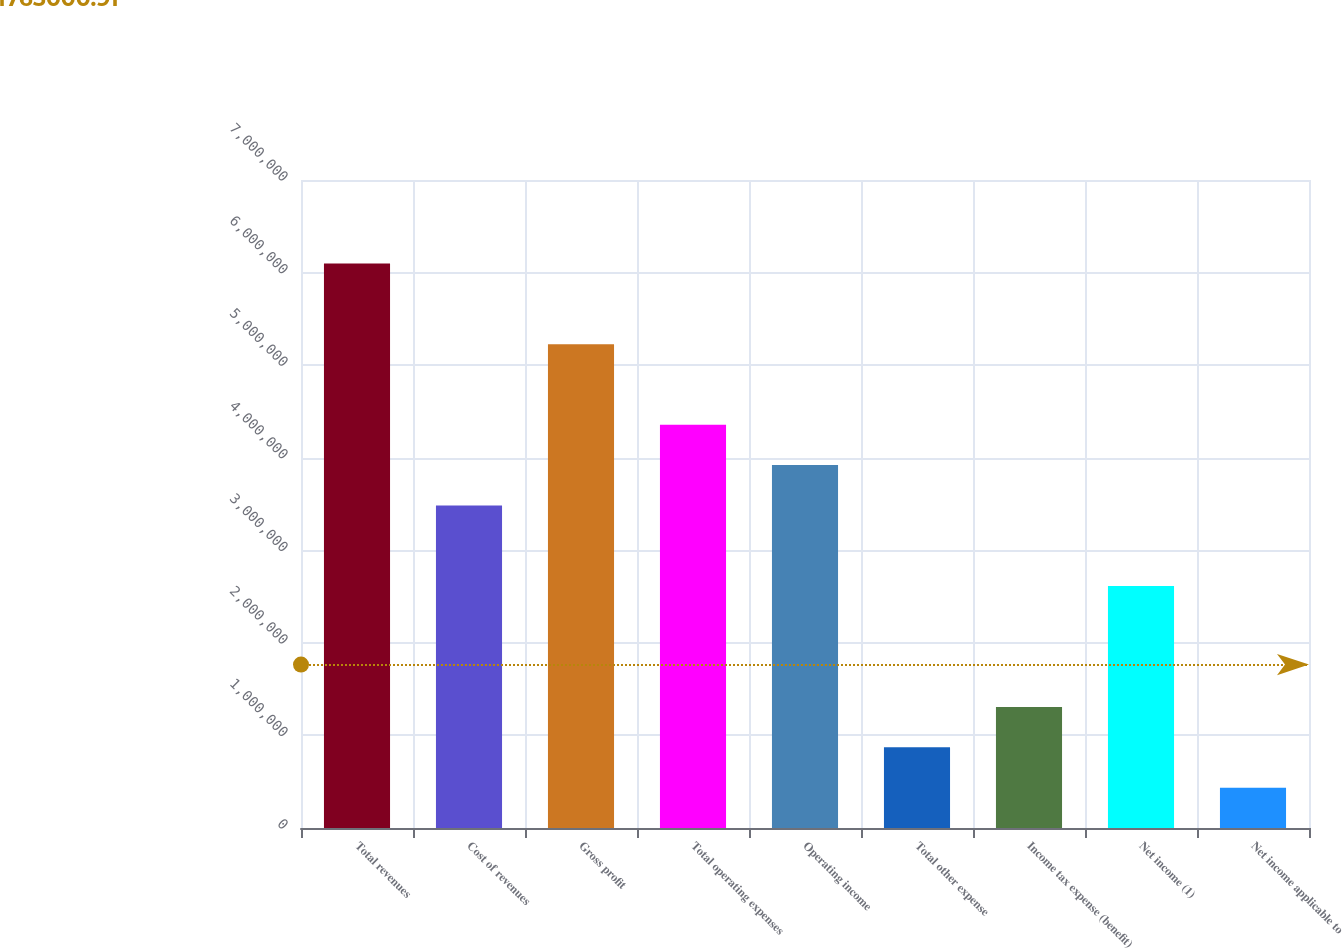Convert chart. <chart><loc_0><loc_0><loc_500><loc_500><bar_chart><fcel>Total revenues<fcel>Cost of revenues<fcel>Gross profit<fcel>Total operating expenses<fcel>Operating income<fcel>Total other expense<fcel>Income tax expense (benefit)<fcel>Net income (1)<fcel>Net income applicable to<nl><fcel>6.09785e+06<fcel>3.48449e+06<fcel>5.22673e+06<fcel>4.35561e+06<fcel>3.92005e+06<fcel>871139<fcel>1.3067e+06<fcel>2.61337e+06<fcel>435580<nl></chart> 